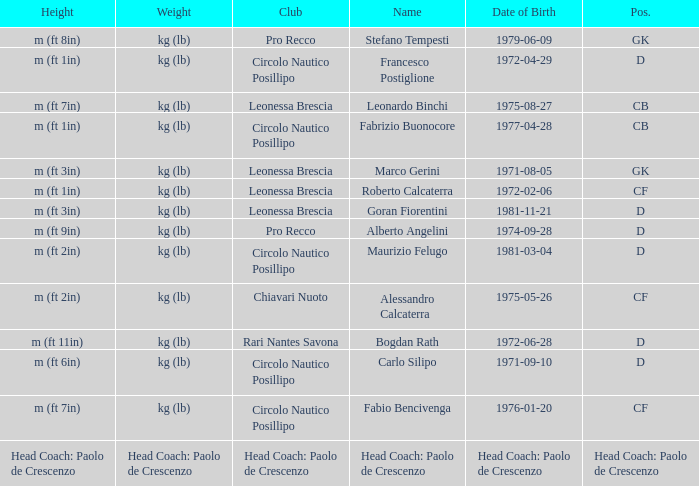What is the position of the player with a height of m (ft 6in)? D. 